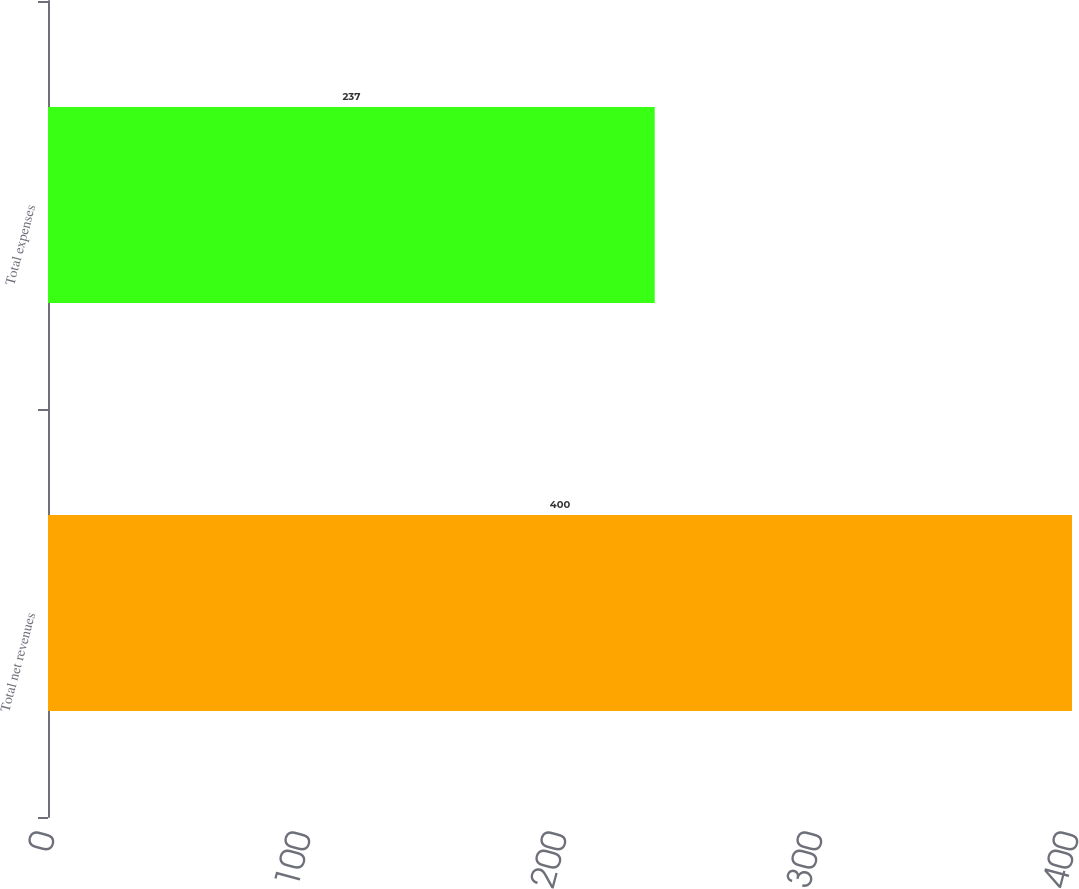Convert chart. <chart><loc_0><loc_0><loc_500><loc_500><bar_chart><fcel>Total net revenues<fcel>Total expenses<nl><fcel>400<fcel>237<nl></chart> 